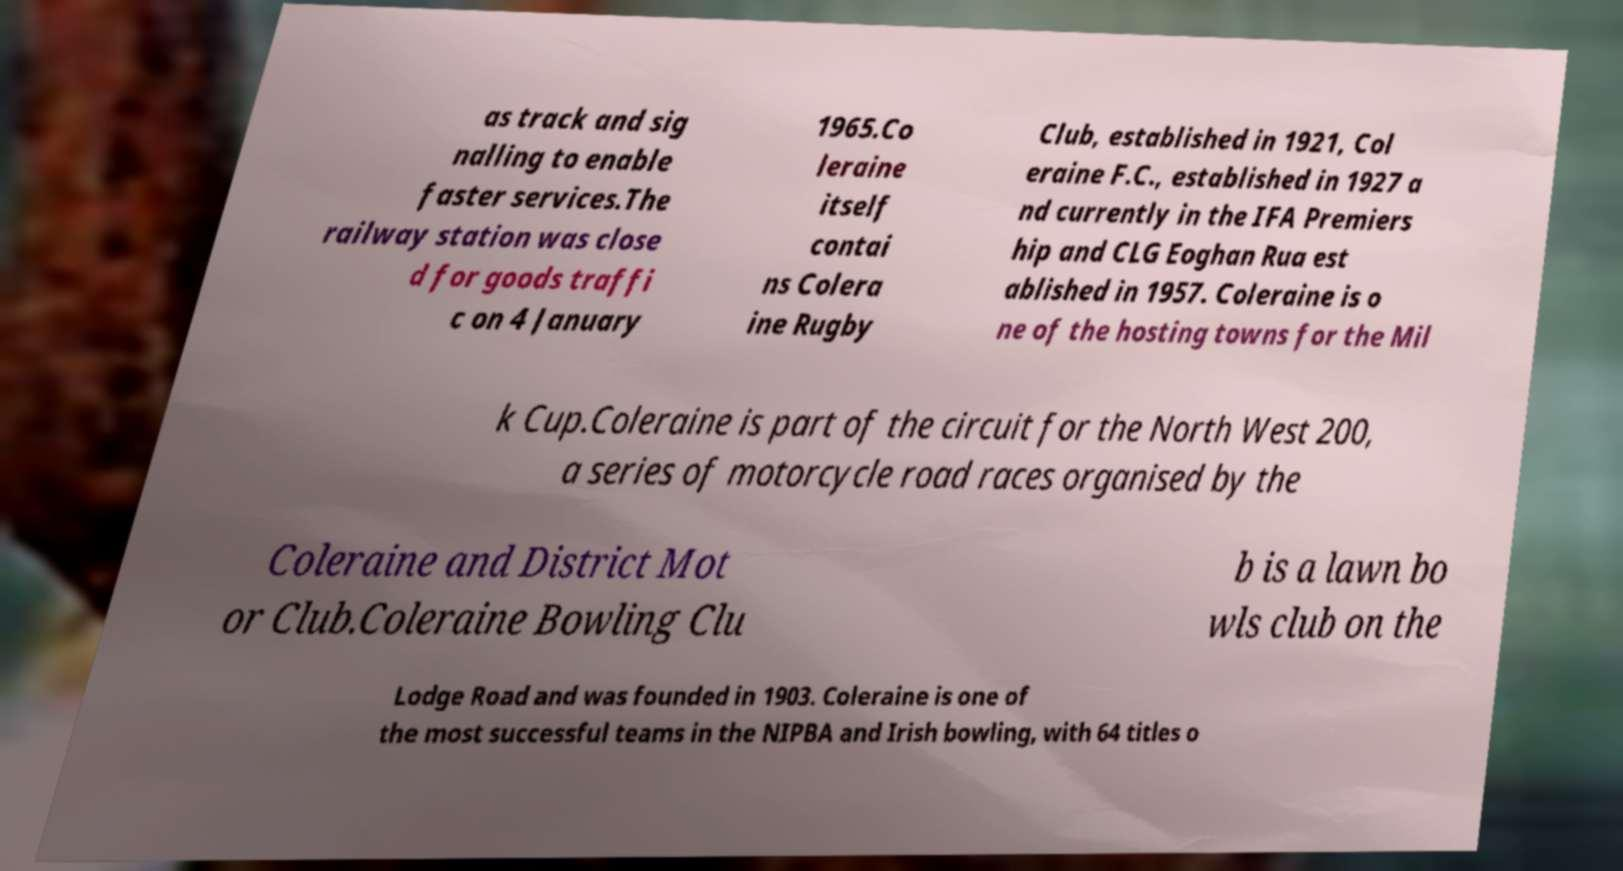There's text embedded in this image that I need extracted. Can you transcribe it verbatim? as track and sig nalling to enable faster services.The railway station was close d for goods traffi c on 4 January 1965.Co leraine itself contai ns Colera ine Rugby Club, established in 1921, Col eraine F.C., established in 1927 a nd currently in the IFA Premiers hip and CLG Eoghan Rua est ablished in 1957. Coleraine is o ne of the hosting towns for the Mil k Cup.Coleraine is part of the circuit for the North West 200, a series of motorcycle road races organised by the Coleraine and District Mot or Club.Coleraine Bowling Clu b is a lawn bo wls club on the Lodge Road and was founded in 1903. Coleraine is one of the most successful teams in the NIPBA and Irish bowling, with 64 titles o 